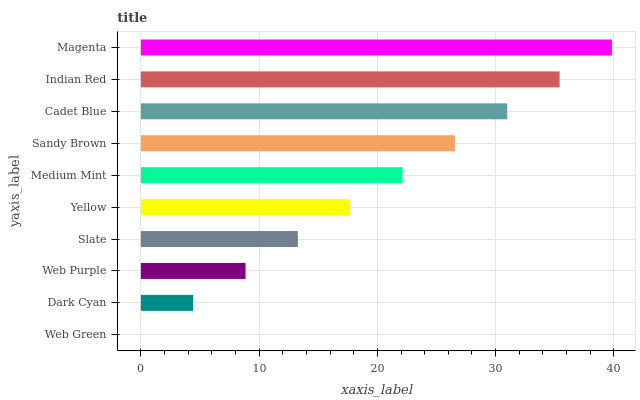Is Web Green the minimum?
Answer yes or no. Yes. Is Magenta the maximum?
Answer yes or no. Yes. Is Dark Cyan the minimum?
Answer yes or no. No. Is Dark Cyan the maximum?
Answer yes or no. No. Is Dark Cyan greater than Web Green?
Answer yes or no. Yes. Is Web Green less than Dark Cyan?
Answer yes or no. Yes. Is Web Green greater than Dark Cyan?
Answer yes or no. No. Is Dark Cyan less than Web Green?
Answer yes or no. No. Is Medium Mint the high median?
Answer yes or no. Yes. Is Yellow the low median?
Answer yes or no. Yes. Is Yellow the high median?
Answer yes or no. No. Is Dark Cyan the low median?
Answer yes or no. No. 